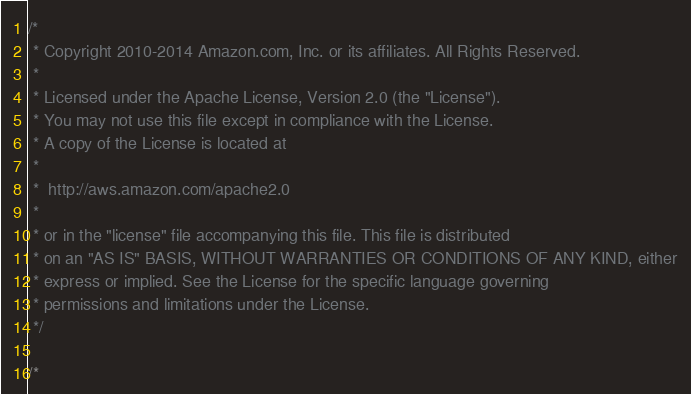<code> <loc_0><loc_0><loc_500><loc_500><_C#_>/*
 * Copyright 2010-2014 Amazon.com, Inc. or its affiliates. All Rights Reserved.
 * 
 * Licensed under the Apache License, Version 2.0 (the "License").
 * You may not use this file except in compliance with the License.
 * A copy of the License is located at
 * 
 *  http://aws.amazon.com/apache2.0
 * 
 * or in the "license" file accompanying this file. This file is distributed
 * on an "AS IS" BASIS, WITHOUT WARRANTIES OR CONDITIONS OF ANY KIND, either
 * express or implied. See the License for the specific language governing
 * permissions and limitations under the License.
 */

/*</code> 